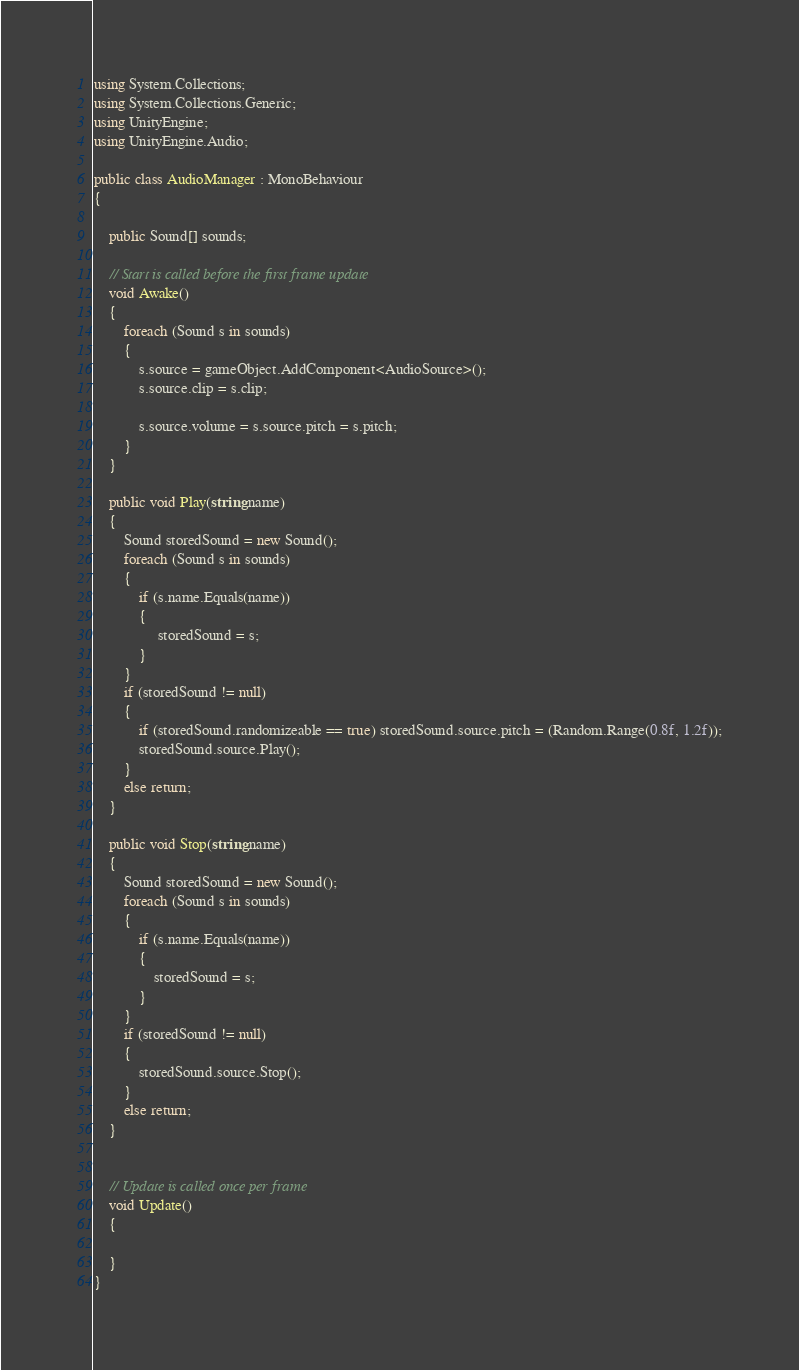<code> <loc_0><loc_0><loc_500><loc_500><_C#_>using System.Collections;
using System.Collections.Generic;
using UnityEngine;
using UnityEngine.Audio;

public class AudioManager : MonoBehaviour
{

    public Sound[] sounds;

    // Start is called before the first frame update
    void Awake()
    {
        foreach (Sound s in sounds)
        {
            s.source = gameObject.AddComponent<AudioSource>();
            s.source.clip = s.clip;

            s.source.volume = s.source.pitch = s.pitch;
        }
    }

    public void Play(string name)
    {
        Sound storedSound = new Sound();
        foreach (Sound s in sounds)
        {
            if (s.name.Equals(name))
            {
                 storedSound = s;
            }
        }
        if (storedSound != null)
        {
            if (storedSound.randomizeable == true) storedSound.source.pitch = (Random.Range(0.8f, 1.2f));
            storedSound.source.Play();
        }
        else return;
    }

    public void Stop(string name)
    {
        Sound storedSound = new Sound();
        foreach (Sound s in sounds)
        {
            if (s.name.Equals(name))
            {
                storedSound = s;
            }
        }
        if (storedSound != null)
        {
            storedSound.source.Stop();
        }
        else return;
    }


    // Update is called once per frame
    void Update()
    {
        
    }
}
</code> 